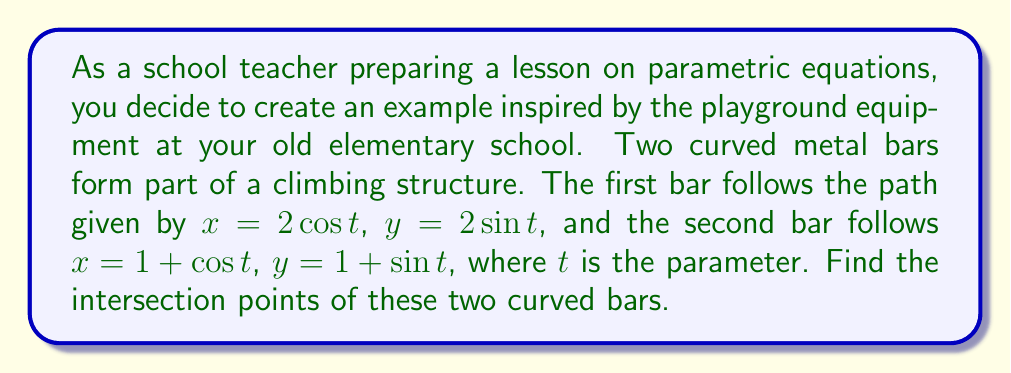Can you solve this math problem? To find the intersection points, we need to solve the system of equations:

$$\begin{cases}
2\cos t = 1 + \cos s \\
2\sin t = 1 + \sin s
\end{cases}$$

Where $t$ and $s$ are independent parameters.

Step 1: Square both equations and add them together.
$$(2\cos t)^2 + (2\sin t)^2 = (1 + \cos s)^2 + (1 + \sin s)^2$$

Step 2: Simplify using trigonometric identities.
$$4(\cos^2 t + \sin^2 t) = 1 + 2\cos s + \cos^2 s + 1 + 2\sin s + \sin^2 s$$
$$4 = 2 + 2(\cos s + \sin s) + (\cos^2 s + \sin^2 s)$$
$$4 = 2 + 2(\cos s + \sin s) + 1$$
$$1 = \cos s + \sin s$$

Step 3: Solve for $s$ using the substitution $u = \tan(s/2)$.
$$\cos s = \frac{1-u^2}{1+u^2}, \sin s = \frac{2u}{1+u^2}$$
$$\frac{1-u^2}{1+u^2} + \frac{2u}{1+u^2} = 1$$
$$1-u^2 + 2u = 1+u^2$$
$$2u = 2u^2$$
$$u(1-u) = 0$$
$$u = 0 \text{ or } u = 1$$

This gives us $s = 0$ or $s = \pi/4$.

Step 4: Substitute these values back into the original equations.
For $s = 0$: $x = 2, y = 1$
For $s = \pi/4$: $x = 1 + \frac{\sqrt{2}}{2}, y = 1 + \frac{\sqrt{2}}{2}$

Step 5: Verify these points satisfy the equations for the first curve.
For $(2, 1)$: $t = 0$
For $(1 + \frac{\sqrt{2}}{2}, 1 + \frac{\sqrt{2}}{2})$: $t = \pi/4$
Answer: The intersection points are $(2, 1)$ and $(1 + \frac{\sqrt{2}}{2}, 1 + \frac{\sqrt{2}}{2})$. 